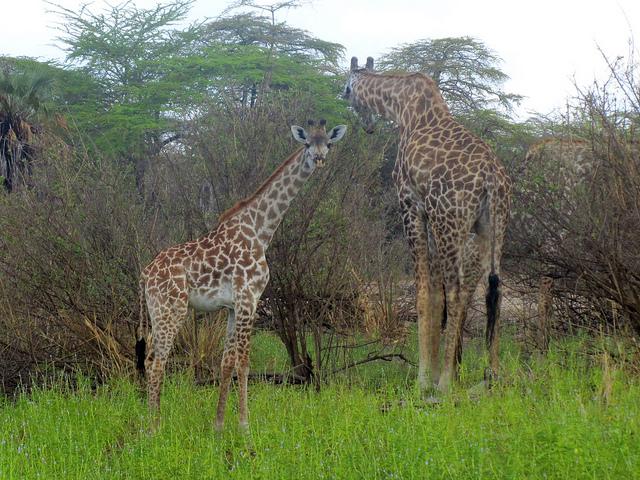Is this a giraffes natural environment?
Quick response, please. Yes. Is the grass green?
Give a very brief answer. Yes. Which animal is taller?
Concise answer only. Right. How many animals are in this photo?
Keep it brief. 2. How many giraffes are there?
Concise answer only. 2. Is the giraffe facing the camera?
Quick response, please. Yes. How many giraffe's are there?
Quick response, please. 2. Are the giraffes the same age?
Short answer required. No. What are the giraffes doing?
Write a very short answer. Eating. How many giraffes are looking toward the camera?
Give a very brief answer. 1. 